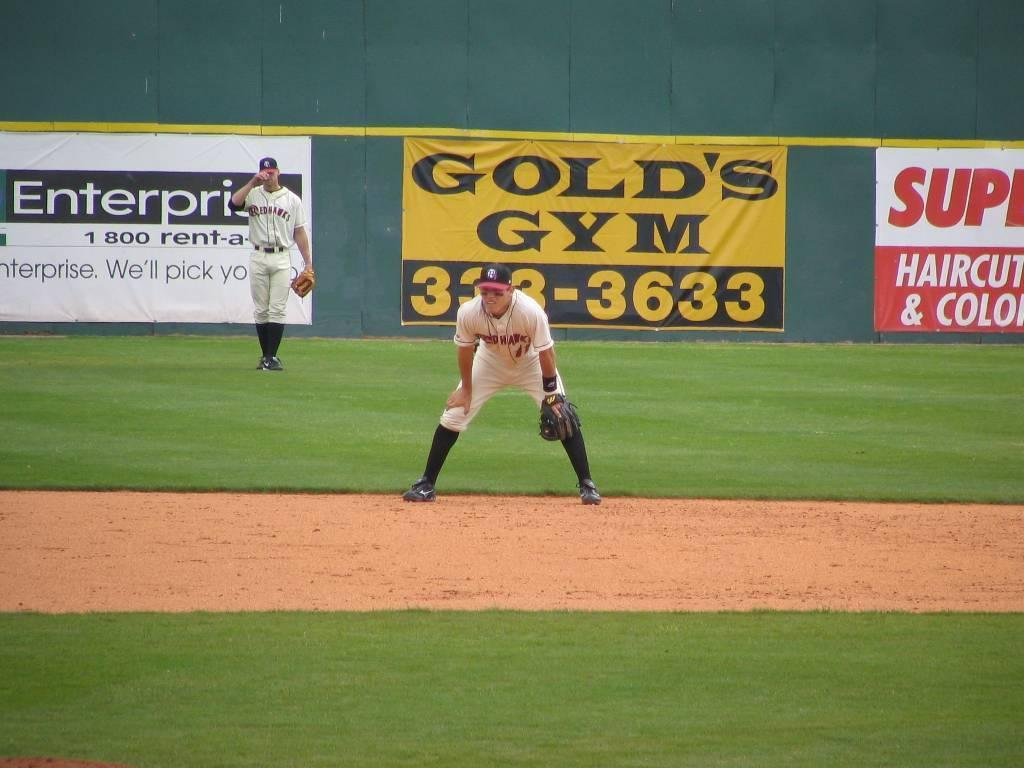<image>
Summarize the visual content of the image. A man with the redhawks team crouches on a baseball field. 